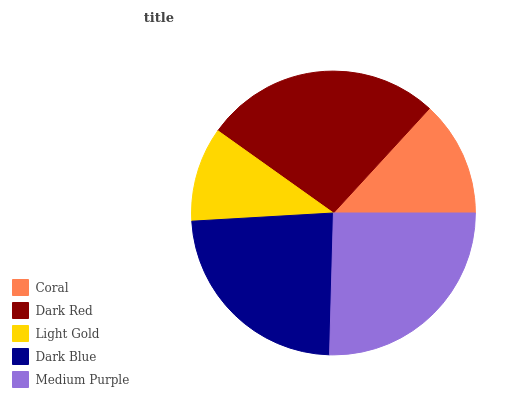Is Light Gold the minimum?
Answer yes or no. Yes. Is Dark Red the maximum?
Answer yes or no. Yes. Is Dark Red the minimum?
Answer yes or no. No. Is Light Gold the maximum?
Answer yes or no. No. Is Dark Red greater than Light Gold?
Answer yes or no. Yes. Is Light Gold less than Dark Red?
Answer yes or no. Yes. Is Light Gold greater than Dark Red?
Answer yes or no. No. Is Dark Red less than Light Gold?
Answer yes or no. No. Is Dark Blue the high median?
Answer yes or no. Yes. Is Dark Blue the low median?
Answer yes or no. Yes. Is Medium Purple the high median?
Answer yes or no. No. Is Light Gold the low median?
Answer yes or no. No. 